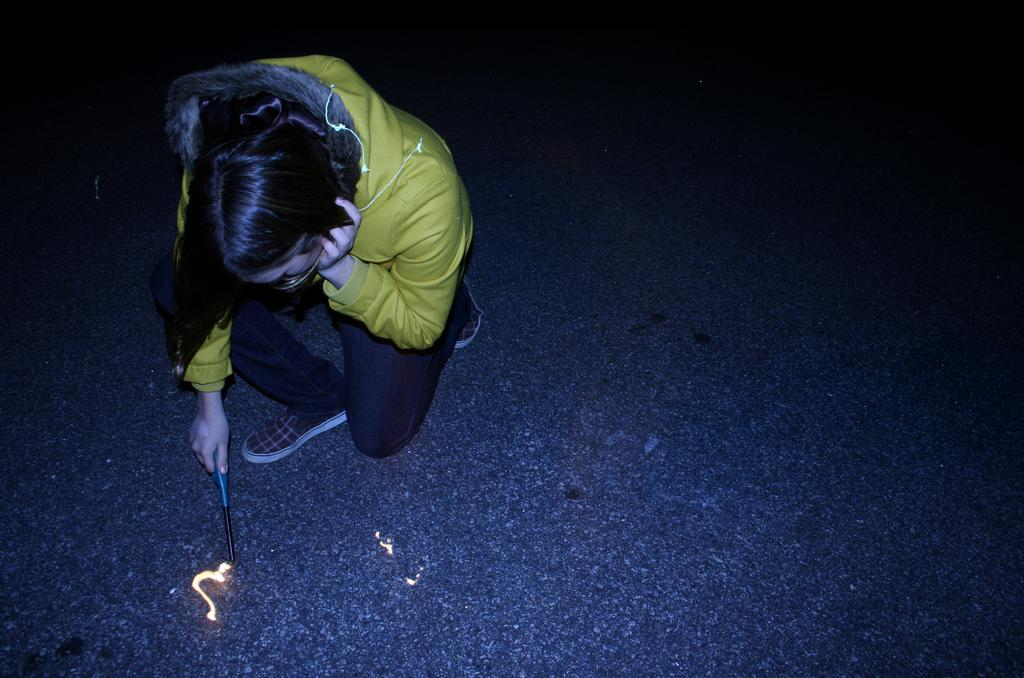What can be seen in the image? There is a person in the image. What is the person holding in his hand? The person is holding an object in his hand. What type of clothing is the person wearing? The person is wearing a hoodie. What type of rhythm can be heard coming from the apparatus in the image? There is no apparatus present in the image, and therefore no rhythm can be heard. 